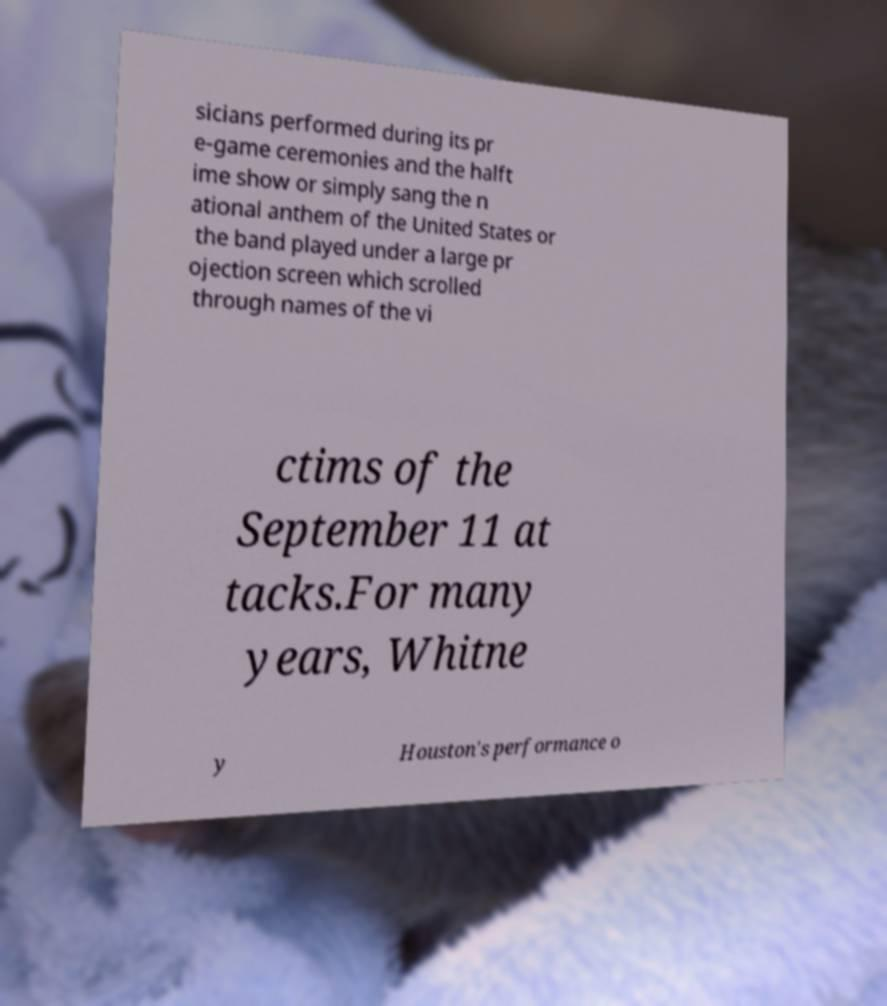Can you read and provide the text displayed in the image?This photo seems to have some interesting text. Can you extract and type it out for me? sicians performed during its pr e-game ceremonies and the halft ime show or simply sang the n ational anthem of the United States or the band played under a large pr ojection screen which scrolled through names of the vi ctims of the September 11 at tacks.For many years, Whitne y Houston's performance o 